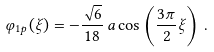<formula> <loc_0><loc_0><loc_500><loc_500>\varphi _ { 1 p } ( \xi ) = - \frac { \sqrt { 6 } } { 1 8 } \, a \cos \left ( \frac { 3 \pi } { 2 } \xi \right ) \, .</formula> 